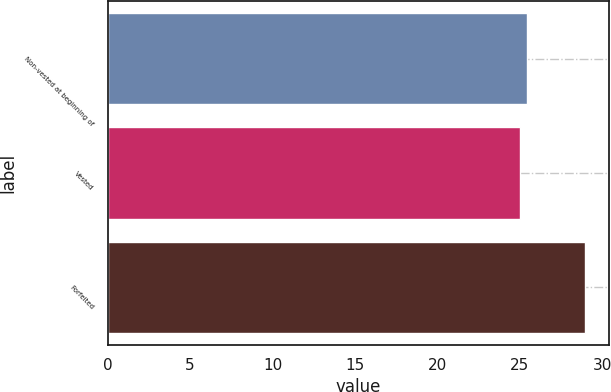Convert chart to OTSL. <chart><loc_0><loc_0><loc_500><loc_500><bar_chart><fcel>Non-vested at beginning of<fcel>Vested<fcel>Forfeited<nl><fcel>25.43<fcel>25.04<fcel>28.99<nl></chart> 